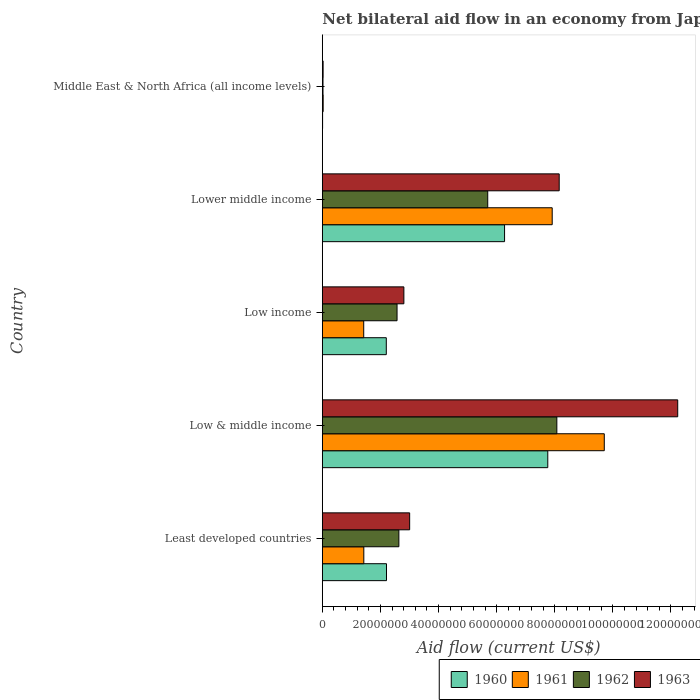How many different coloured bars are there?
Give a very brief answer. 4. What is the net bilateral aid flow in 1962 in Lower middle income?
Keep it short and to the point. 5.69e+07. Across all countries, what is the maximum net bilateral aid flow in 1960?
Offer a terse response. 7.76e+07. In which country was the net bilateral aid flow in 1960 maximum?
Make the answer very short. Low & middle income. In which country was the net bilateral aid flow in 1963 minimum?
Offer a terse response. Middle East & North Africa (all income levels). What is the total net bilateral aid flow in 1963 in the graph?
Your answer should be compact. 2.62e+08. What is the difference between the net bilateral aid flow in 1960 in Least developed countries and that in Low & middle income?
Offer a terse response. -5.55e+07. What is the difference between the net bilateral aid flow in 1960 in Middle East & North Africa (all income levels) and the net bilateral aid flow in 1962 in Low income?
Make the answer very short. -2.56e+07. What is the average net bilateral aid flow in 1960 per country?
Offer a terse response. 3.69e+07. What is the difference between the net bilateral aid flow in 1963 and net bilateral aid flow in 1961 in Least developed countries?
Make the answer very short. 1.58e+07. In how many countries, is the net bilateral aid flow in 1963 greater than 28000000 US$?
Your response must be concise. 4. What is the ratio of the net bilateral aid flow in 1960 in Least developed countries to that in Low & middle income?
Give a very brief answer. 0.28. Is the net bilateral aid flow in 1961 in Low income less than that in Lower middle income?
Your answer should be very brief. Yes. What is the difference between the highest and the second highest net bilateral aid flow in 1961?
Ensure brevity in your answer.  1.79e+07. What is the difference between the highest and the lowest net bilateral aid flow in 1960?
Provide a short and direct response. 7.75e+07. Is the sum of the net bilateral aid flow in 1963 in Least developed countries and Low & middle income greater than the maximum net bilateral aid flow in 1960 across all countries?
Ensure brevity in your answer.  Yes. What does the 1st bar from the bottom in Low & middle income represents?
Provide a short and direct response. 1960. Is it the case that in every country, the sum of the net bilateral aid flow in 1962 and net bilateral aid flow in 1961 is greater than the net bilateral aid flow in 1963?
Offer a terse response. Yes. How many bars are there?
Ensure brevity in your answer.  20. Are all the bars in the graph horizontal?
Provide a succinct answer. Yes. Does the graph contain grids?
Your answer should be very brief. No. How many legend labels are there?
Provide a short and direct response. 4. How are the legend labels stacked?
Offer a very short reply. Horizontal. What is the title of the graph?
Your response must be concise. Net bilateral aid flow in an economy from Japan. Does "1980" appear as one of the legend labels in the graph?
Provide a short and direct response. No. What is the Aid flow (current US$) in 1960 in Least developed countries?
Provide a short and direct response. 2.21e+07. What is the Aid flow (current US$) of 1961 in Least developed countries?
Ensure brevity in your answer.  1.43e+07. What is the Aid flow (current US$) of 1962 in Least developed countries?
Provide a short and direct response. 2.64e+07. What is the Aid flow (current US$) in 1963 in Least developed countries?
Offer a very short reply. 3.01e+07. What is the Aid flow (current US$) in 1960 in Low & middle income?
Make the answer very short. 7.76e+07. What is the Aid flow (current US$) in 1961 in Low & middle income?
Your answer should be compact. 9.71e+07. What is the Aid flow (current US$) in 1962 in Low & middle income?
Your answer should be very brief. 8.07e+07. What is the Aid flow (current US$) in 1963 in Low & middle income?
Offer a terse response. 1.22e+08. What is the Aid flow (current US$) of 1960 in Low income?
Keep it short and to the point. 2.20e+07. What is the Aid flow (current US$) of 1961 in Low income?
Ensure brevity in your answer.  1.42e+07. What is the Aid flow (current US$) in 1962 in Low income?
Give a very brief answer. 2.57e+07. What is the Aid flow (current US$) of 1963 in Low income?
Offer a very short reply. 2.81e+07. What is the Aid flow (current US$) in 1960 in Lower middle income?
Your answer should be very brief. 6.27e+07. What is the Aid flow (current US$) in 1961 in Lower middle income?
Your response must be concise. 7.91e+07. What is the Aid flow (current US$) in 1962 in Lower middle income?
Your response must be concise. 5.69e+07. What is the Aid flow (current US$) of 1963 in Lower middle income?
Ensure brevity in your answer.  8.15e+07. What is the Aid flow (current US$) in 1961 in Middle East & North Africa (all income levels)?
Ensure brevity in your answer.  2.90e+05. What is the Aid flow (current US$) of 1963 in Middle East & North Africa (all income levels)?
Offer a very short reply. 2.70e+05. Across all countries, what is the maximum Aid flow (current US$) of 1960?
Provide a succinct answer. 7.76e+07. Across all countries, what is the maximum Aid flow (current US$) of 1961?
Make the answer very short. 9.71e+07. Across all countries, what is the maximum Aid flow (current US$) of 1962?
Give a very brief answer. 8.07e+07. Across all countries, what is the maximum Aid flow (current US$) in 1963?
Provide a short and direct response. 1.22e+08. Across all countries, what is the minimum Aid flow (current US$) in 1960?
Your answer should be compact. 9.00e+04. Across all countries, what is the minimum Aid flow (current US$) of 1962?
Provide a succinct answer. 2.30e+05. What is the total Aid flow (current US$) of 1960 in the graph?
Make the answer very short. 1.85e+08. What is the total Aid flow (current US$) of 1961 in the graph?
Offer a terse response. 2.05e+08. What is the total Aid flow (current US$) in 1962 in the graph?
Your answer should be compact. 1.90e+08. What is the total Aid flow (current US$) of 1963 in the graph?
Your answer should be compact. 2.62e+08. What is the difference between the Aid flow (current US$) in 1960 in Least developed countries and that in Low & middle income?
Give a very brief answer. -5.55e+07. What is the difference between the Aid flow (current US$) of 1961 in Least developed countries and that in Low & middle income?
Your response must be concise. -8.28e+07. What is the difference between the Aid flow (current US$) in 1962 in Least developed countries and that in Low & middle income?
Your answer should be compact. -5.44e+07. What is the difference between the Aid flow (current US$) in 1963 in Least developed countries and that in Low & middle income?
Your response must be concise. -9.23e+07. What is the difference between the Aid flow (current US$) of 1961 in Least developed countries and that in Low income?
Keep it short and to the point. 3.00e+04. What is the difference between the Aid flow (current US$) in 1962 in Least developed countries and that in Low income?
Provide a short and direct response. 6.30e+05. What is the difference between the Aid flow (current US$) in 1963 in Least developed countries and that in Low income?
Offer a very short reply. 1.99e+06. What is the difference between the Aid flow (current US$) in 1960 in Least developed countries and that in Lower middle income?
Offer a terse response. -4.06e+07. What is the difference between the Aid flow (current US$) in 1961 in Least developed countries and that in Lower middle income?
Give a very brief answer. -6.48e+07. What is the difference between the Aid flow (current US$) of 1962 in Least developed countries and that in Lower middle income?
Give a very brief answer. -3.06e+07. What is the difference between the Aid flow (current US$) of 1963 in Least developed countries and that in Lower middle income?
Offer a terse response. -5.15e+07. What is the difference between the Aid flow (current US$) in 1960 in Least developed countries and that in Middle East & North Africa (all income levels)?
Your answer should be very brief. 2.20e+07. What is the difference between the Aid flow (current US$) in 1961 in Least developed countries and that in Middle East & North Africa (all income levels)?
Make the answer very short. 1.40e+07. What is the difference between the Aid flow (current US$) in 1962 in Least developed countries and that in Middle East & North Africa (all income levels)?
Your response must be concise. 2.61e+07. What is the difference between the Aid flow (current US$) of 1963 in Least developed countries and that in Middle East & North Africa (all income levels)?
Your answer should be very brief. 2.98e+07. What is the difference between the Aid flow (current US$) of 1960 in Low & middle income and that in Low income?
Your answer should be very brief. 5.56e+07. What is the difference between the Aid flow (current US$) of 1961 in Low & middle income and that in Low income?
Offer a very short reply. 8.28e+07. What is the difference between the Aid flow (current US$) in 1962 in Low & middle income and that in Low income?
Make the answer very short. 5.50e+07. What is the difference between the Aid flow (current US$) in 1963 in Low & middle income and that in Low income?
Your response must be concise. 9.43e+07. What is the difference between the Aid flow (current US$) in 1960 in Low & middle income and that in Lower middle income?
Make the answer very short. 1.49e+07. What is the difference between the Aid flow (current US$) of 1961 in Low & middle income and that in Lower middle income?
Make the answer very short. 1.79e+07. What is the difference between the Aid flow (current US$) of 1962 in Low & middle income and that in Lower middle income?
Offer a very short reply. 2.38e+07. What is the difference between the Aid flow (current US$) in 1963 in Low & middle income and that in Lower middle income?
Ensure brevity in your answer.  4.08e+07. What is the difference between the Aid flow (current US$) of 1960 in Low & middle income and that in Middle East & North Africa (all income levels)?
Give a very brief answer. 7.75e+07. What is the difference between the Aid flow (current US$) of 1961 in Low & middle income and that in Middle East & North Africa (all income levels)?
Provide a short and direct response. 9.68e+07. What is the difference between the Aid flow (current US$) of 1962 in Low & middle income and that in Middle East & North Africa (all income levels)?
Provide a short and direct response. 8.05e+07. What is the difference between the Aid flow (current US$) in 1963 in Low & middle income and that in Middle East & North Africa (all income levels)?
Your response must be concise. 1.22e+08. What is the difference between the Aid flow (current US$) in 1960 in Low income and that in Lower middle income?
Offer a terse response. -4.07e+07. What is the difference between the Aid flow (current US$) of 1961 in Low income and that in Lower middle income?
Your answer should be compact. -6.49e+07. What is the difference between the Aid flow (current US$) of 1962 in Low income and that in Lower middle income?
Make the answer very short. -3.12e+07. What is the difference between the Aid flow (current US$) in 1963 in Low income and that in Lower middle income?
Provide a short and direct response. -5.35e+07. What is the difference between the Aid flow (current US$) in 1960 in Low income and that in Middle East & North Africa (all income levels)?
Offer a very short reply. 2.19e+07. What is the difference between the Aid flow (current US$) of 1961 in Low income and that in Middle East & North Africa (all income levels)?
Your answer should be compact. 1.40e+07. What is the difference between the Aid flow (current US$) of 1962 in Low income and that in Middle East & North Africa (all income levels)?
Provide a short and direct response. 2.55e+07. What is the difference between the Aid flow (current US$) of 1963 in Low income and that in Middle East & North Africa (all income levels)?
Keep it short and to the point. 2.78e+07. What is the difference between the Aid flow (current US$) of 1960 in Lower middle income and that in Middle East & North Africa (all income levels)?
Provide a succinct answer. 6.26e+07. What is the difference between the Aid flow (current US$) in 1961 in Lower middle income and that in Middle East & North Africa (all income levels)?
Your answer should be very brief. 7.88e+07. What is the difference between the Aid flow (current US$) of 1962 in Lower middle income and that in Middle East & North Africa (all income levels)?
Your response must be concise. 5.67e+07. What is the difference between the Aid flow (current US$) of 1963 in Lower middle income and that in Middle East & North Africa (all income levels)?
Your answer should be compact. 8.13e+07. What is the difference between the Aid flow (current US$) in 1960 in Least developed countries and the Aid flow (current US$) in 1961 in Low & middle income?
Your response must be concise. -7.50e+07. What is the difference between the Aid flow (current US$) of 1960 in Least developed countries and the Aid flow (current US$) of 1962 in Low & middle income?
Offer a very short reply. -5.86e+07. What is the difference between the Aid flow (current US$) in 1960 in Least developed countries and the Aid flow (current US$) in 1963 in Low & middle income?
Offer a terse response. -1.00e+08. What is the difference between the Aid flow (current US$) of 1961 in Least developed countries and the Aid flow (current US$) of 1962 in Low & middle income?
Your answer should be compact. -6.64e+07. What is the difference between the Aid flow (current US$) of 1961 in Least developed countries and the Aid flow (current US$) of 1963 in Low & middle income?
Provide a short and direct response. -1.08e+08. What is the difference between the Aid flow (current US$) in 1962 in Least developed countries and the Aid flow (current US$) in 1963 in Low & middle income?
Offer a terse response. -9.60e+07. What is the difference between the Aid flow (current US$) in 1960 in Least developed countries and the Aid flow (current US$) in 1961 in Low income?
Your answer should be compact. 7.84e+06. What is the difference between the Aid flow (current US$) of 1960 in Least developed countries and the Aid flow (current US$) of 1962 in Low income?
Offer a terse response. -3.63e+06. What is the difference between the Aid flow (current US$) in 1960 in Least developed countries and the Aid flow (current US$) in 1963 in Low income?
Your answer should be compact. -5.98e+06. What is the difference between the Aid flow (current US$) of 1961 in Least developed countries and the Aid flow (current US$) of 1962 in Low income?
Your response must be concise. -1.14e+07. What is the difference between the Aid flow (current US$) in 1961 in Least developed countries and the Aid flow (current US$) in 1963 in Low income?
Offer a terse response. -1.38e+07. What is the difference between the Aid flow (current US$) of 1962 in Least developed countries and the Aid flow (current US$) of 1963 in Low income?
Keep it short and to the point. -1.72e+06. What is the difference between the Aid flow (current US$) of 1960 in Least developed countries and the Aid flow (current US$) of 1961 in Lower middle income?
Give a very brief answer. -5.70e+07. What is the difference between the Aid flow (current US$) in 1960 in Least developed countries and the Aid flow (current US$) in 1962 in Lower middle income?
Offer a very short reply. -3.48e+07. What is the difference between the Aid flow (current US$) in 1960 in Least developed countries and the Aid flow (current US$) in 1963 in Lower middle income?
Your answer should be very brief. -5.94e+07. What is the difference between the Aid flow (current US$) in 1961 in Least developed countries and the Aid flow (current US$) in 1962 in Lower middle income?
Your answer should be very brief. -4.27e+07. What is the difference between the Aid flow (current US$) in 1961 in Least developed countries and the Aid flow (current US$) in 1963 in Lower middle income?
Give a very brief answer. -6.73e+07. What is the difference between the Aid flow (current US$) of 1962 in Least developed countries and the Aid flow (current US$) of 1963 in Lower middle income?
Keep it short and to the point. -5.52e+07. What is the difference between the Aid flow (current US$) of 1960 in Least developed countries and the Aid flow (current US$) of 1961 in Middle East & North Africa (all income levels)?
Ensure brevity in your answer.  2.18e+07. What is the difference between the Aid flow (current US$) of 1960 in Least developed countries and the Aid flow (current US$) of 1962 in Middle East & North Africa (all income levels)?
Keep it short and to the point. 2.19e+07. What is the difference between the Aid flow (current US$) in 1960 in Least developed countries and the Aid flow (current US$) in 1963 in Middle East & North Africa (all income levels)?
Keep it short and to the point. 2.18e+07. What is the difference between the Aid flow (current US$) of 1961 in Least developed countries and the Aid flow (current US$) of 1962 in Middle East & North Africa (all income levels)?
Keep it short and to the point. 1.40e+07. What is the difference between the Aid flow (current US$) in 1961 in Least developed countries and the Aid flow (current US$) in 1963 in Middle East & North Africa (all income levels)?
Ensure brevity in your answer.  1.40e+07. What is the difference between the Aid flow (current US$) of 1962 in Least developed countries and the Aid flow (current US$) of 1963 in Middle East & North Africa (all income levels)?
Your answer should be very brief. 2.61e+07. What is the difference between the Aid flow (current US$) of 1960 in Low & middle income and the Aid flow (current US$) of 1961 in Low income?
Make the answer very short. 6.34e+07. What is the difference between the Aid flow (current US$) of 1960 in Low & middle income and the Aid flow (current US$) of 1962 in Low income?
Make the answer very short. 5.19e+07. What is the difference between the Aid flow (current US$) of 1960 in Low & middle income and the Aid flow (current US$) of 1963 in Low income?
Ensure brevity in your answer.  4.95e+07. What is the difference between the Aid flow (current US$) in 1961 in Low & middle income and the Aid flow (current US$) in 1962 in Low income?
Give a very brief answer. 7.13e+07. What is the difference between the Aid flow (current US$) of 1961 in Low & middle income and the Aid flow (current US$) of 1963 in Low income?
Make the answer very short. 6.90e+07. What is the difference between the Aid flow (current US$) in 1962 in Low & middle income and the Aid flow (current US$) in 1963 in Low income?
Provide a succinct answer. 5.27e+07. What is the difference between the Aid flow (current US$) of 1960 in Low & middle income and the Aid flow (current US$) of 1961 in Lower middle income?
Your answer should be very brief. -1.52e+06. What is the difference between the Aid flow (current US$) of 1960 in Low & middle income and the Aid flow (current US$) of 1962 in Lower middle income?
Your answer should be very brief. 2.07e+07. What is the difference between the Aid flow (current US$) of 1960 in Low & middle income and the Aid flow (current US$) of 1963 in Lower middle income?
Provide a succinct answer. -3.93e+06. What is the difference between the Aid flow (current US$) of 1961 in Low & middle income and the Aid flow (current US$) of 1962 in Lower middle income?
Ensure brevity in your answer.  4.01e+07. What is the difference between the Aid flow (current US$) in 1961 in Low & middle income and the Aid flow (current US$) in 1963 in Lower middle income?
Provide a succinct answer. 1.55e+07. What is the difference between the Aid flow (current US$) in 1962 in Low & middle income and the Aid flow (current US$) in 1963 in Lower middle income?
Provide a short and direct response. -8.10e+05. What is the difference between the Aid flow (current US$) in 1960 in Low & middle income and the Aid flow (current US$) in 1961 in Middle East & North Africa (all income levels)?
Provide a succinct answer. 7.73e+07. What is the difference between the Aid flow (current US$) in 1960 in Low & middle income and the Aid flow (current US$) in 1962 in Middle East & North Africa (all income levels)?
Offer a terse response. 7.74e+07. What is the difference between the Aid flow (current US$) of 1960 in Low & middle income and the Aid flow (current US$) of 1963 in Middle East & North Africa (all income levels)?
Offer a terse response. 7.73e+07. What is the difference between the Aid flow (current US$) in 1961 in Low & middle income and the Aid flow (current US$) in 1962 in Middle East & North Africa (all income levels)?
Your response must be concise. 9.68e+07. What is the difference between the Aid flow (current US$) of 1961 in Low & middle income and the Aid flow (current US$) of 1963 in Middle East & North Africa (all income levels)?
Make the answer very short. 9.68e+07. What is the difference between the Aid flow (current US$) of 1962 in Low & middle income and the Aid flow (current US$) of 1963 in Middle East & North Africa (all income levels)?
Offer a terse response. 8.05e+07. What is the difference between the Aid flow (current US$) in 1960 in Low income and the Aid flow (current US$) in 1961 in Lower middle income?
Provide a succinct answer. -5.71e+07. What is the difference between the Aid flow (current US$) in 1960 in Low income and the Aid flow (current US$) in 1962 in Lower middle income?
Keep it short and to the point. -3.49e+07. What is the difference between the Aid flow (current US$) of 1960 in Low income and the Aid flow (current US$) of 1963 in Lower middle income?
Give a very brief answer. -5.95e+07. What is the difference between the Aid flow (current US$) of 1961 in Low income and the Aid flow (current US$) of 1962 in Lower middle income?
Give a very brief answer. -4.27e+07. What is the difference between the Aid flow (current US$) in 1961 in Low income and the Aid flow (current US$) in 1963 in Lower middle income?
Offer a very short reply. -6.73e+07. What is the difference between the Aid flow (current US$) in 1962 in Low income and the Aid flow (current US$) in 1963 in Lower middle income?
Offer a terse response. -5.58e+07. What is the difference between the Aid flow (current US$) of 1960 in Low income and the Aid flow (current US$) of 1961 in Middle East & North Africa (all income levels)?
Your answer should be compact. 2.17e+07. What is the difference between the Aid flow (current US$) in 1960 in Low income and the Aid flow (current US$) in 1962 in Middle East & North Africa (all income levels)?
Ensure brevity in your answer.  2.18e+07. What is the difference between the Aid flow (current US$) in 1960 in Low income and the Aid flow (current US$) in 1963 in Middle East & North Africa (all income levels)?
Provide a short and direct response. 2.18e+07. What is the difference between the Aid flow (current US$) in 1961 in Low income and the Aid flow (current US$) in 1962 in Middle East & North Africa (all income levels)?
Give a very brief answer. 1.40e+07. What is the difference between the Aid flow (current US$) in 1961 in Low income and the Aid flow (current US$) in 1963 in Middle East & North Africa (all income levels)?
Your answer should be compact. 1.40e+07. What is the difference between the Aid flow (current US$) in 1962 in Low income and the Aid flow (current US$) in 1963 in Middle East & North Africa (all income levels)?
Offer a terse response. 2.54e+07. What is the difference between the Aid flow (current US$) in 1960 in Lower middle income and the Aid flow (current US$) in 1961 in Middle East & North Africa (all income levels)?
Give a very brief answer. 6.24e+07. What is the difference between the Aid flow (current US$) in 1960 in Lower middle income and the Aid flow (current US$) in 1962 in Middle East & North Africa (all income levels)?
Provide a succinct answer. 6.25e+07. What is the difference between the Aid flow (current US$) of 1960 in Lower middle income and the Aid flow (current US$) of 1963 in Middle East & North Africa (all income levels)?
Offer a terse response. 6.25e+07. What is the difference between the Aid flow (current US$) of 1961 in Lower middle income and the Aid flow (current US$) of 1962 in Middle East & North Africa (all income levels)?
Keep it short and to the point. 7.89e+07. What is the difference between the Aid flow (current US$) of 1961 in Lower middle income and the Aid flow (current US$) of 1963 in Middle East & North Africa (all income levels)?
Your response must be concise. 7.89e+07. What is the difference between the Aid flow (current US$) of 1962 in Lower middle income and the Aid flow (current US$) of 1963 in Middle East & North Africa (all income levels)?
Keep it short and to the point. 5.67e+07. What is the average Aid flow (current US$) in 1960 per country?
Provide a short and direct response. 3.69e+07. What is the average Aid flow (current US$) in 1961 per country?
Provide a succinct answer. 4.10e+07. What is the average Aid flow (current US$) in 1962 per country?
Your answer should be compact. 3.80e+07. What is the average Aid flow (current US$) of 1963 per country?
Offer a very short reply. 5.25e+07. What is the difference between the Aid flow (current US$) of 1960 and Aid flow (current US$) of 1961 in Least developed countries?
Your answer should be very brief. 7.81e+06. What is the difference between the Aid flow (current US$) in 1960 and Aid flow (current US$) in 1962 in Least developed countries?
Keep it short and to the point. -4.26e+06. What is the difference between the Aid flow (current US$) in 1960 and Aid flow (current US$) in 1963 in Least developed countries?
Provide a succinct answer. -7.97e+06. What is the difference between the Aid flow (current US$) of 1961 and Aid flow (current US$) of 1962 in Least developed countries?
Your answer should be compact. -1.21e+07. What is the difference between the Aid flow (current US$) in 1961 and Aid flow (current US$) in 1963 in Least developed countries?
Offer a terse response. -1.58e+07. What is the difference between the Aid flow (current US$) in 1962 and Aid flow (current US$) in 1963 in Least developed countries?
Make the answer very short. -3.71e+06. What is the difference between the Aid flow (current US$) of 1960 and Aid flow (current US$) of 1961 in Low & middle income?
Keep it short and to the point. -1.94e+07. What is the difference between the Aid flow (current US$) of 1960 and Aid flow (current US$) of 1962 in Low & middle income?
Provide a succinct answer. -3.12e+06. What is the difference between the Aid flow (current US$) in 1960 and Aid flow (current US$) in 1963 in Low & middle income?
Provide a short and direct response. -4.47e+07. What is the difference between the Aid flow (current US$) of 1961 and Aid flow (current US$) of 1962 in Low & middle income?
Keep it short and to the point. 1.63e+07. What is the difference between the Aid flow (current US$) of 1961 and Aid flow (current US$) of 1963 in Low & middle income?
Your answer should be compact. -2.53e+07. What is the difference between the Aid flow (current US$) of 1962 and Aid flow (current US$) of 1963 in Low & middle income?
Ensure brevity in your answer.  -4.16e+07. What is the difference between the Aid flow (current US$) in 1960 and Aid flow (current US$) in 1961 in Low income?
Ensure brevity in your answer.  7.77e+06. What is the difference between the Aid flow (current US$) of 1960 and Aid flow (current US$) of 1962 in Low income?
Provide a succinct answer. -3.70e+06. What is the difference between the Aid flow (current US$) of 1960 and Aid flow (current US$) of 1963 in Low income?
Give a very brief answer. -6.05e+06. What is the difference between the Aid flow (current US$) in 1961 and Aid flow (current US$) in 1962 in Low income?
Your answer should be very brief. -1.15e+07. What is the difference between the Aid flow (current US$) in 1961 and Aid flow (current US$) in 1963 in Low income?
Keep it short and to the point. -1.38e+07. What is the difference between the Aid flow (current US$) in 1962 and Aid flow (current US$) in 1963 in Low income?
Provide a succinct answer. -2.35e+06. What is the difference between the Aid flow (current US$) of 1960 and Aid flow (current US$) of 1961 in Lower middle income?
Provide a short and direct response. -1.64e+07. What is the difference between the Aid flow (current US$) in 1960 and Aid flow (current US$) in 1962 in Lower middle income?
Your answer should be very brief. 5.79e+06. What is the difference between the Aid flow (current US$) of 1960 and Aid flow (current US$) of 1963 in Lower middle income?
Keep it short and to the point. -1.88e+07. What is the difference between the Aid flow (current US$) in 1961 and Aid flow (current US$) in 1962 in Lower middle income?
Give a very brief answer. 2.22e+07. What is the difference between the Aid flow (current US$) of 1961 and Aid flow (current US$) of 1963 in Lower middle income?
Your response must be concise. -2.41e+06. What is the difference between the Aid flow (current US$) in 1962 and Aid flow (current US$) in 1963 in Lower middle income?
Offer a very short reply. -2.46e+07. What is the difference between the Aid flow (current US$) of 1960 and Aid flow (current US$) of 1961 in Middle East & North Africa (all income levels)?
Provide a succinct answer. -2.00e+05. What is the difference between the Aid flow (current US$) of 1960 and Aid flow (current US$) of 1962 in Middle East & North Africa (all income levels)?
Your answer should be very brief. -1.40e+05. What is the difference between the Aid flow (current US$) in 1960 and Aid flow (current US$) in 1963 in Middle East & North Africa (all income levels)?
Give a very brief answer. -1.80e+05. What is the difference between the Aid flow (current US$) in 1961 and Aid flow (current US$) in 1963 in Middle East & North Africa (all income levels)?
Provide a succinct answer. 2.00e+04. What is the ratio of the Aid flow (current US$) in 1960 in Least developed countries to that in Low & middle income?
Your response must be concise. 0.28. What is the ratio of the Aid flow (current US$) in 1961 in Least developed countries to that in Low & middle income?
Give a very brief answer. 0.15. What is the ratio of the Aid flow (current US$) in 1962 in Least developed countries to that in Low & middle income?
Offer a very short reply. 0.33. What is the ratio of the Aid flow (current US$) in 1963 in Least developed countries to that in Low & middle income?
Provide a short and direct response. 0.25. What is the ratio of the Aid flow (current US$) in 1960 in Least developed countries to that in Low income?
Make the answer very short. 1. What is the ratio of the Aid flow (current US$) in 1962 in Least developed countries to that in Low income?
Ensure brevity in your answer.  1.02. What is the ratio of the Aid flow (current US$) of 1963 in Least developed countries to that in Low income?
Provide a succinct answer. 1.07. What is the ratio of the Aid flow (current US$) of 1960 in Least developed countries to that in Lower middle income?
Provide a succinct answer. 0.35. What is the ratio of the Aid flow (current US$) of 1961 in Least developed countries to that in Lower middle income?
Your answer should be compact. 0.18. What is the ratio of the Aid flow (current US$) in 1962 in Least developed countries to that in Lower middle income?
Offer a very short reply. 0.46. What is the ratio of the Aid flow (current US$) of 1963 in Least developed countries to that in Lower middle income?
Ensure brevity in your answer.  0.37. What is the ratio of the Aid flow (current US$) of 1960 in Least developed countries to that in Middle East & North Africa (all income levels)?
Offer a very short reply. 245.44. What is the ratio of the Aid flow (current US$) in 1961 in Least developed countries to that in Middle East & North Africa (all income levels)?
Your answer should be very brief. 49.24. What is the ratio of the Aid flow (current US$) in 1962 in Least developed countries to that in Middle East & North Africa (all income levels)?
Your answer should be very brief. 114.57. What is the ratio of the Aid flow (current US$) in 1963 in Least developed countries to that in Middle East & North Africa (all income levels)?
Your answer should be compact. 111.33. What is the ratio of the Aid flow (current US$) in 1960 in Low & middle income to that in Low income?
Your answer should be very brief. 3.52. What is the ratio of the Aid flow (current US$) of 1961 in Low & middle income to that in Low income?
Provide a short and direct response. 6.81. What is the ratio of the Aid flow (current US$) in 1962 in Low & middle income to that in Low income?
Offer a very short reply. 3.14. What is the ratio of the Aid flow (current US$) in 1963 in Low & middle income to that in Low income?
Your answer should be very brief. 4.36. What is the ratio of the Aid flow (current US$) in 1960 in Low & middle income to that in Lower middle income?
Give a very brief answer. 1.24. What is the ratio of the Aid flow (current US$) of 1961 in Low & middle income to that in Lower middle income?
Your response must be concise. 1.23. What is the ratio of the Aid flow (current US$) in 1962 in Low & middle income to that in Lower middle income?
Offer a very short reply. 1.42. What is the ratio of the Aid flow (current US$) in 1963 in Low & middle income to that in Lower middle income?
Give a very brief answer. 1.5. What is the ratio of the Aid flow (current US$) of 1960 in Low & middle income to that in Middle East & North Africa (all income levels)?
Keep it short and to the point. 862.33. What is the ratio of the Aid flow (current US$) of 1961 in Low & middle income to that in Middle East & North Africa (all income levels)?
Your answer should be compact. 334.69. What is the ratio of the Aid flow (current US$) in 1962 in Low & middle income to that in Middle East & North Africa (all income levels)?
Keep it short and to the point. 351. What is the ratio of the Aid flow (current US$) in 1963 in Low & middle income to that in Middle East & North Africa (all income levels)?
Keep it short and to the point. 453.11. What is the ratio of the Aid flow (current US$) in 1960 in Low income to that in Lower middle income?
Offer a terse response. 0.35. What is the ratio of the Aid flow (current US$) in 1961 in Low income to that in Lower middle income?
Ensure brevity in your answer.  0.18. What is the ratio of the Aid flow (current US$) of 1962 in Low income to that in Lower middle income?
Give a very brief answer. 0.45. What is the ratio of the Aid flow (current US$) in 1963 in Low income to that in Lower middle income?
Keep it short and to the point. 0.34. What is the ratio of the Aid flow (current US$) in 1960 in Low income to that in Middle East & North Africa (all income levels)?
Your response must be concise. 244.67. What is the ratio of the Aid flow (current US$) in 1961 in Low income to that in Middle East & North Africa (all income levels)?
Give a very brief answer. 49.14. What is the ratio of the Aid flow (current US$) of 1962 in Low income to that in Middle East & North Africa (all income levels)?
Ensure brevity in your answer.  111.83. What is the ratio of the Aid flow (current US$) in 1963 in Low income to that in Middle East & North Africa (all income levels)?
Your answer should be compact. 103.96. What is the ratio of the Aid flow (current US$) of 1960 in Lower middle income to that in Middle East & North Africa (all income levels)?
Offer a terse response. 697. What is the ratio of the Aid flow (current US$) in 1961 in Lower middle income to that in Middle East & North Africa (all income levels)?
Keep it short and to the point. 272.86. What is the ratio of the Aid flow (current US$) in 1962 in Lower middle income to that in Middle East & North Africa (all income levels)?
Provide a short and direct response. 247.57. What is the ratio of the Aid flow (current US$) in 1963 in Lower middle income to that in Middle East & North Africa (all income levels)?
Offer a very short reply. 302. What is the difference between the highest and the second highest Aid flow (current US$) of 1960?
Give a very brief answer. 1.49e+07. What is the difference between the highest and the second highest Aid flow (current US$) in 1961?
Make the answer very short. 1.79e+07. What is the difference between the highest and the second highest Aid flow (current US$) in 1962?
Make the answer very short. 2.38e+07. What is the difference between the highest and the second highest Aid flow (current US$) of 1963?
Make the answer very short. 4.08e+07. What is the difference between the highest and the lowest Aid flow (current US$) in 1960?
Ensure brevity in your answer.  7.75e+07. What is the difference between the highest and the lowest Aid flow (current US$) in 1961?
Your answer should be very brief. 9.68e+07. What is the difference between the highest and the lowest Aid flow (current US$) of 1962?
Provide a short and direct response. 8.05e+07. What is the difference between the highest and the lowest Aid flow (current US$) of 1963?
Your response must be concise. 1.22e+08. 